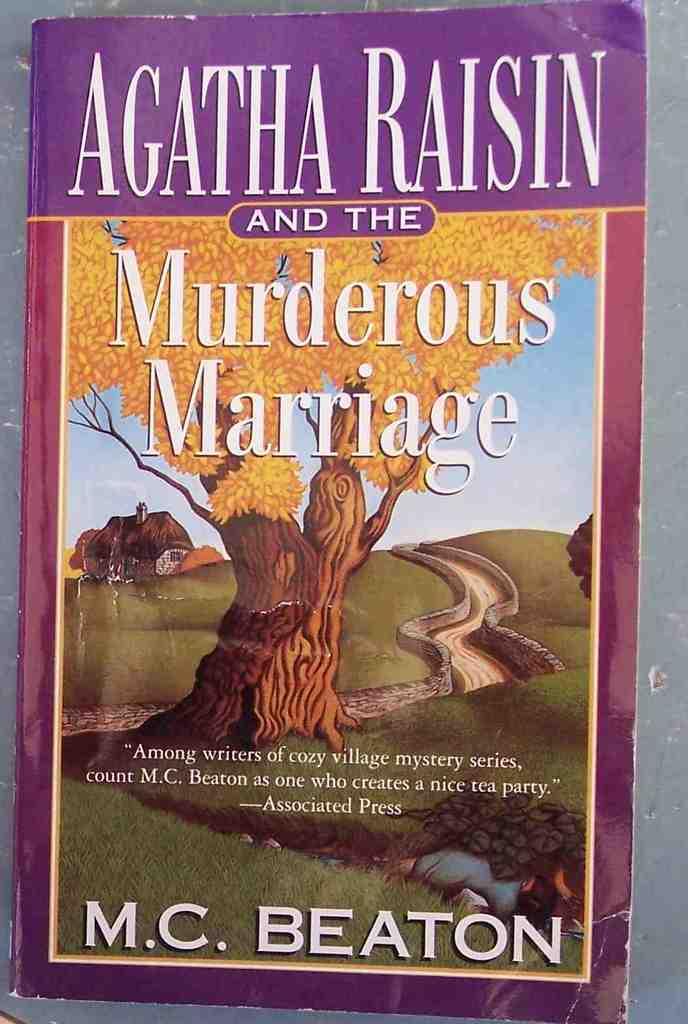Who wrote this book?
Your response must be concise. M.c. beaton. 